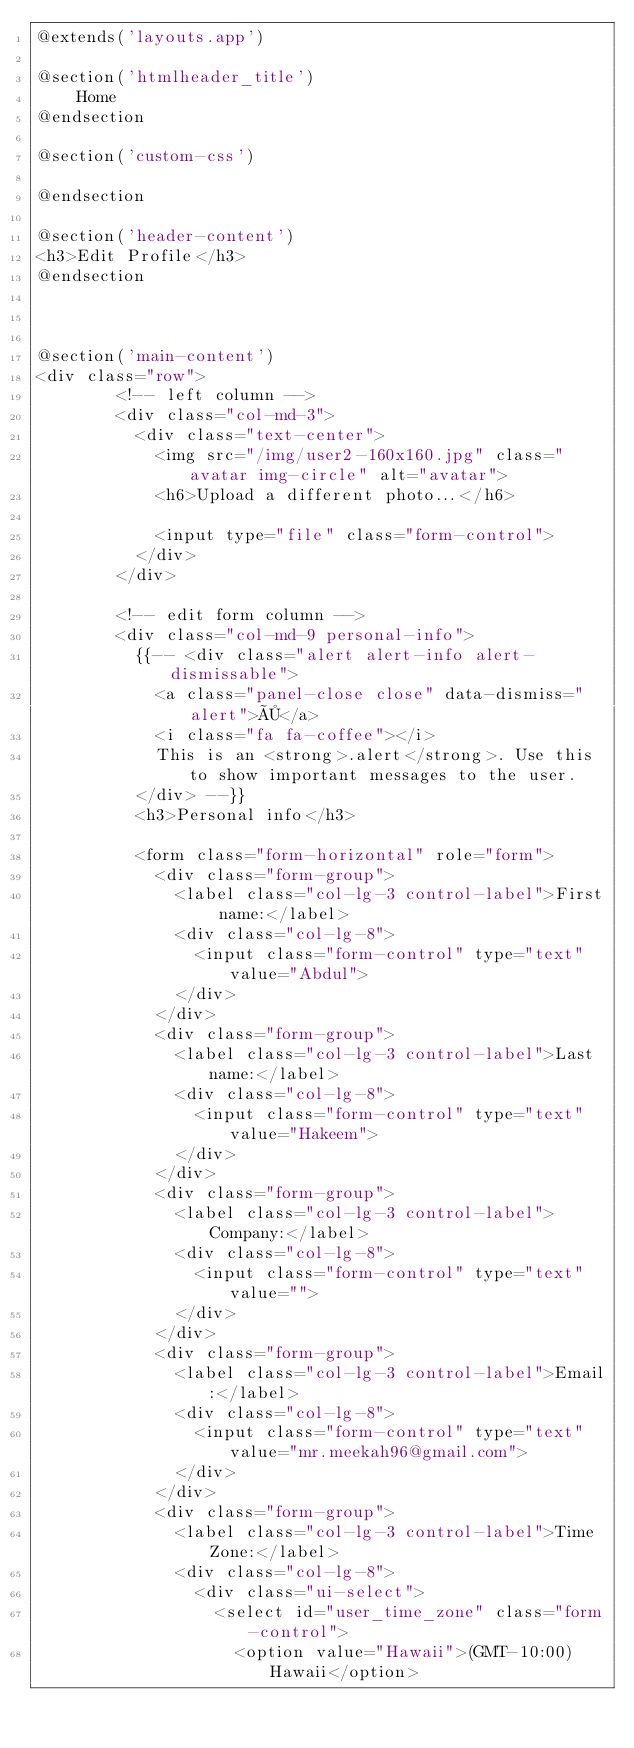Convert code to text. <code><loc_0><loc_0><loc_500><loc_500><_PHP_>@extends('layouts.app')

@section('htmlheader_title')
	Home
@endsection

@section('custom-css')	

@endsection

@section('header-content')	
<h3>Edit Profile</h3>
@endsection



@section('main-content')
<div class="row">
		<!-- left column -->
		<div class="col-md-3">
		  <div class="text-center">
			<img src="/img/user2-160x160.jpg" class="avatar img-circle" alt="avatar">
			<h6>Upload a different photo...</h6>
			
			<input type="file" class="form-control">
		  </div>
		</div>
		
		<!-- edit form column -->
		<div class="col-md-9 personal-info">
		  {{-- <div class="alert alert-info alert-dismissable">
			<a class="panel-close close" data-dismiss="alert">×</a> 
			<i class="fa fa-coffee"></i>
			This is an <strong>.alert</strong>. Use this to show important messages to the user.
		  </div> --}}
		  <h3>Personal info</h3>
		  
		  <form class="form-horizontal" role="form">
			<div class="form-group">
			  <label class="col-lg-3 control-label">First name:</label>
			  <div class="col-lg-8">
				<input class="form-control" type="text" value="Abdul">
			  </div>
			</div>
			<div class="form-group">
			  <label class="col-lg-3 control-label">Last name:</label>
			  <div class="col-lg-8">
				<input class="form-control" type="text" value="Hakeem">
			  </div>
			</div>
			<div class="form-group">
			  <label class="col-lg-3 control-label">Company:</label>
			  <div class="col-lg-8">
				<input class="form-control" type="text" value="">
			  </div>
			</div>
			<div class="form-group">
			  <label class="col-lg-3 control-label">Email:</label>
			  <div class="col-lg-8">
				<input class="form-control" type="text" value="mr.meekah96@gmail.com">
			  </div>
			</div>
			<div class="form-group">
			  <label class="col-lg-3 control-label">Time Zone:</label>
			  <div class="col-lg-8">
				<div class="ui-select">
				  <select id="user_time_zone" class="form-control">
					<option value="Hawaii">(GMT-10:00) Hawaii</option></code> 